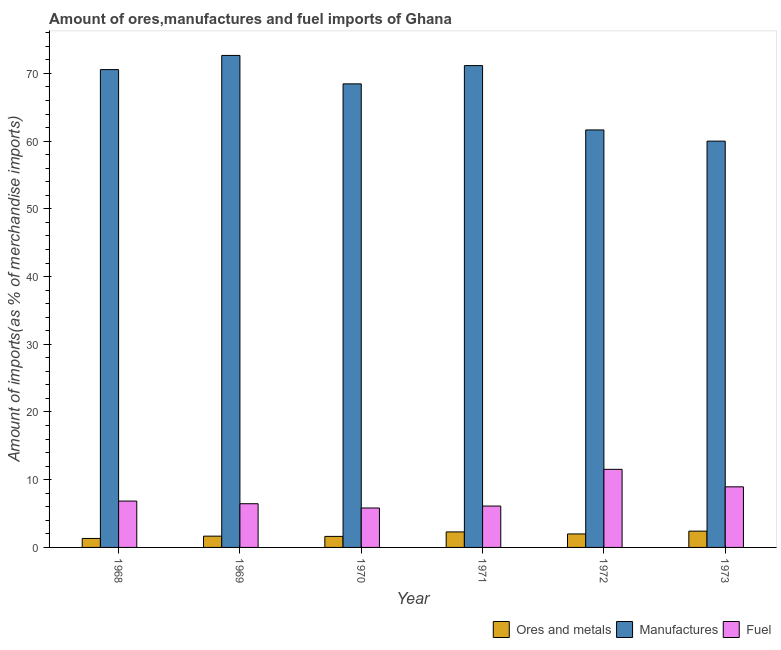How many different coloured bars are there?
Ensure brevity in your answer.  3. Are the number of bars per tick equal to the number of legend labels?
Provide a succinct answer. Yes. Are the number of bars on each tick of the X-axis equal?
Ensure brevity in your answer.  Yes. How many bars are there on the 4th tick from the right?
Provide a short and direct response. 3. What is the label of the 1st group of bars from the left?
Ensure brevity in your answer.  1968. In how many cases, is the number of bars for a given year not equal to the number of legend labels?
Your response must be concise. 0. What is the percentage of fuel imports in 1973?
Your answer should be very brief. 8.95. Across all years, what is the maximum percentage of ores and metals imports?
Give a very brief answer. 2.41. Across all years, what is the minimum percentage of fuel imports?
Give a very brief answer. 5.82. In which year was the percentage of fuel imports maximum?
Give a very brief answer. 1972. What is the total percentage of manufactures imports in the graph?
Offer a terse response. 404.46. What is the difference between the percentage of fuel imports in 1968 and that in 1972?
Keep it short and to the point. -4.69. What is the difference between the percentage of ores and metals imports in 1973 and the percentage of fuel imports in 1970?
Your response must be concise. 0.78. What is the average percentage of manufactures imports per year?
Keep it short and to the point. 67.41. In the year 1971, what is the difference between the percentage of ores and metals imports and percentage of fuel imports?
Your response must be concise. 0. In how many years, is the percentage of fuel imports greater than 68 %?
Keep it short and to the point. 0. What is the ratio of the percentage of fuel imports in 1969 to that in 1973?
Your answer should be compact. 0.72. Is the difference between the percentage of fuel imports in 1969 and 1970 greater than the difference between the percentage of manufactures imports in 1969 and 1970?
Make the answer very short. No. What is the difference between the highest and the second highest percentage of ores and metals imports?
Make the answer very short. 0.11. What is the difference between the highest and the lowest percentage of fuel imports?
Provide a short and direct response. 5.71. In how many years, is the percentage of fuel imports greater than the average percentage of fuel imports taken over all years?
Offer a terse response. 2. Is the sum of the percentage of fuel imports in 1969 and 1972 greater than the maximum percentage of ores and metals imports across all years?
Your answer should be compact. Yes. What does the 3rd bar from the left in 1970 represents?
Give a very brief answer. Fuel. What does the 2nd bar from the right in 1972 represents?
Your answer should be compact. Manufactures. How many bars are there?
Keep it short and to the point. 18. Does the graph contain any zero values?
Your answer should be very brief. No. How many legend labels are there?
Keep it short and to the point. 3. How are the legend labels stacked?
Ensure brevity in your answer.  Horizontal. What is the title of the graph?
Keep it short and to the point. Amount of ores,manufactures and fuel imports of Ghana. What is the label or title of the Y-axis?
Your answer should be compact. Amount of imports(as % of merchandise imports). What is the Amount of imports(as % of merchandise imports) of Ores and metals in 1968?
Offer a terse response. 1.33. What is the Amount of imports(as % of merchandise imports) in Manufactures in 1968?
Keep it short and to the point. 70.56. What is the Amount of imports(as % of merchandise imports) of Fuel in 1968?
Your answer should be very brief. 6.84. What is the Amount of imports(as % of merchandise imports) of Ores and metals in 1969?
Make the answer very short. 1.67. What is the Amount of imports(as % of merchandise imports) of Manufactures in 1969?
Provide a succinct answer. 72.65. What is the Amount of imports(as % of merchandise imports) in Fuel in 1969?
Your response must be concise. 6.45. What is the Amount of imports(as % of merchandise imports) in Ores and metals in 1970?
Provide a short and direct response. 1.63. What is the Amount of imports(as % of merchandise imports) in Manufactures in 1970?
Make the answer very short. 68.45. What is the Amount of imports(as % of merchandise imports) in Fuel in 1970?
Your answer should be very brief. 5.82. What is the Amount of imports(as % of merchandise imports) of Ores and metals in 1971?
Ensure brevity in your answer.  2.29. What is the Amount of imports(as % of merchandise imports) of Manufactures in 1971?
Give a very brief answer. 71.15. What is the Amount of imports(as % of merchandise imports) of Fuel in 1971?
Keep it short and to the point. 6.11. What is the Amount of imports(as % of merchandise imports) of Ores and metals in 1972?
Your answer should be compact. 1.99. What is the Amount of imports(as % of merchandise imports) of Manufactures in 1972?
Your answer should be very brief. 61.65. What is the Amount of imports(as % of merchandise imports) in Fuel in 1972?
Offer a very short reply. 11.53. What is the Amount of imports(as % of merchandise imports) in Ores and metals in 1973?
Ensure brevity in your answer.  2.41. What is the Amount of imports(as % of merchandise imports) of Manufactures in 1973?
Offer a terse response. 60. What is the Amount of imports(as % of merchandise imports) of Fuel in 1973?
Offer a very short reply. 8.95. Across all years, what is the maximum Amount of imports(as % of merchandise imports) in Ores and metals?
Provide a succinct answer. 2.41. Across all years, what is the maximum Amount of imports(as % of merchandise imports) of Manufactures?
Keep it short and to the point. 72.65. Across all years, what is the maximum Amount of imports(as % of merchandise imports) in Fuel?
Your answer should be compact. 11.53. Across all years, what is the minimum Amount of imports(as % of merchandise imports) of Ores and metals?
Give a very brief answer. 1.33. Across all years, what is the minimum Amount of imports(as % of merchandise imports) in Manufactures?
Offer a very short reply. 60. Across all years, what is the minimum Amount of imports(as % of merchandise imports) in Fuel?
Make the answer very short. 5.82. What is the total Amount of imports(as % of merchandise imports) of Ores and metals in the graph?
Your answer should be very brief. 11.31. What is the total Amount of imports(as % of merchandise imports) in Manufactures in the graph?
Make the answer very short. 404.46. What is the total Amount of imports(as % of merchandise imports) in Fuel in the graph?
Provide a short and direct response. 45.71. What is the difference between the Amount of imports(as % of merchandise imports) of Ores and metals in 1968 and that in 1969?
Ensure brevity in your answer.  -0.34. What is the difference between the Amount of imports(as % of merchandise imports) in Manufactures in 1968 and that in 1969?
Give a very brief answer. -2.09. What is the difference between the Amount of imports(as % of merchandise imports) of Fuel in 1968 and that in 1969?
Your answer should be compact. 0.39. What is the difference between the Amount of imports(as % of merchandise imports) in Ores and metals in 1968 and that in 1970?
Make the answer very short. -0.3. What is the difference between the Amount of imports(as % of merchandise imports) of Manufactures in 1968 and that in 1970?
Ensure brevity in your answer.  2.1. What is the difference between the Amount of imports(as % of merchandise imports) of Fuel in 1968 and that in 1970?
Offer a terse response. 1.02. What is the difference between the Amount of imports(as % of merchandise imports) of Ores and metals in 1968 and that in 1971?
Ensure brevity in your answer.  -0.96. What is the difference between the Amount of imports(as % of merchandise imports) in Manufactures in 1968 and that in 1971?
Provide a succinct answer. -0.59. What is the difference between the Amount of imports(as % of merchandise imports) of Fuel in 1968 and that in 1971?
Provide a succinct answer. 0.74. What is the difference between the Amount of imports(as % of merchandise imports) in Ores and metals in 1968 and that in 1972?
Give a very brief answer. -0.67. What is the difference between the Amount of imports(as % of merchandise imports) of Manufactures in 1968 and that in 1972?
Keep it short and to the point. 8.91. What is the difference between the Amount of imports(as % of merchandise imports) in Fuel in 1968 and that in 1972?
Keep it short and to the point. -4.69. What is the difference between the Amount of imports(as % of merchandise imports) of Ores and metals in 1968 and that in 1973?
Keep it short and to the point. -1.08. What is the difference between the Amount of imports(as % of merchandise imports) in Manufactures in 1968 and that in 1973?
Ensure brevity in your answer.  10.56. What is the difference between the Amount of imports(as % of merchandise imports) of Fuel in 1968 and that in 1973?
Your answer should be very brief. -2.1. What is the difference between the Amount of imports(as % of merchandise imports) of Ores and metals in 1969 and that in 1970?
Give a very brief answer. 0.04. What is the difference between the Amount of imports(as % of merchandise imports) in Manufactures in 1969 and that in 1970?
Provide a short and direct response. 4.2. What is the difference between the Amount of imports(as % of merchandise imports) in Fuel in 1969 and that in 1970?
Your answer should be compact. 0.63. What is the difference between the Amount of imports(as % of merchandise imports) of Ores and metals in 1969 and that in 1971?
Your response must be concise. -0.63. What is the difference between the Amount of imports(as % of merchandise imports) of Manufactures in 1969 and that in 1971?
Ensure brevity in your answer.  1.5. What is the difference between the Amount of imports(as % of merchandise imports) in Fuel in 1969 and that in 1971?
Offer a very short reply. 0.34. What is the difference between the Amount of imports(as % of merchandise imports) of Ores and metals in 1969 and that in 1972?
Give a very brief answer. -0.33. What is the difference between the Amount of imports(as % of merchandise imports) in Manufactures in 1969 and that in 1972?
Your answer should be compact. 11. What is the difference between the Amount of imports(as % of merchandise imports) of Fuel in 1969 and that in 1972?
Give a very brief answer. -5.08. What is the difference between the Amount of imports(as % of merchandise imports) in Ores and metals in 1969 and that in 1973?
Your answer should be compact. -0.74. What is the difference between the Amount of imports(as % of merchandise imports) in Manufactures in 1969 and that in 1973?
Your answer should be compact. 12.66. What is the difference between the Amount of imports(as % of merchandise imports) in Fuel in 1969 and that in 1973?
Provide a succinct answer. -2.49. What is the difference between the Amount of imports(as % of merchandise imports) of Ores and metals in 1970 and that in 1971?
Make the answer very short. -0.66. What is the difference between the Amount of imports(as % of merchandise imports) in Manufactures in 1970 and that in 1971?
Keep it short and to the point. -2.7. What is the difference between the Amount of imports(as % of merchandise imports) in Fuel in 1970 and that in 1971?
Keep it short and to the point. -0.29. What is the difference between the Amount of imports(as % of merchandise imports) of Ores and metals in 1970 and that in 1972?
Make the answer very short. -0.36. What is the difference between the Amount of imports(as % of merchandise imports) of Manufactures in 1970 and that in 1972?
Keep it short and to the point. 6.8. What is the difference between the Amount of imports(as % of merchandise imports) in Fuel in 1970 and that in 1972?
Give a very brief answer. -5.71. What is the difference between the Amount of imports(as % of merchandise imports) of Ores and metals in 1970 and that in 1973?
Provide a short and direct response. -0.78. What is the difference between the Amount of imports(as % of merchandise imports) of Manufactures in 1970 and that in 1973?
Your answer should be very brief. 8.46. What is the difference between the Amount of imports(as % of merchandise imports) of Fuel in 1970 and that in 1973?
Offer a very short reply. -3.12. What is the difference between the Amount of imports(as % of merchandise imports) of Ores and metals in 1971 and that in 1972?
Your answer should be compact. 0.3. What is the difference between the Amount of imports(as % of merchandise imports) of Manufactures in 1971 and that in 1972?
Offer a very short reply. 9.5. What is the difference between the Amount of imports(as % of merchandise imports) in Fuel in 1971 and that in 1972?
Make the answer very short. -5.42. What is the difference between the Amount of imports(as % of merchandise imports) in Ores and metals in 1971 and that in 1973?
Make the answer very short. -0.11. What is the difference between the Amount of imports(as % of merchandise imports) of Manufactures in 1971 and that in 1973?
Your response must be concise. 11.16. What is the difference between the Amount of imports(as % of merchandise imports) of Fuel in 1971 and that in 1973?
Your answer should be very brief. -2.84. What is the difference between the Amount of imports(as % of merchandise imports) of Ores and metals in 1972 and that in 1973?
Offer a very short reply. -0.41. What is the difference between the Amount of imports(as % of merchandise imports) of Manufactures in 1972 and that in 1973?
Offer a very short reply. 1.65. What is the difference between the Amount of imports(as % of merchandise imports) in Fuel in 1972 and that in 1973?
Keep it short and to the point. 2.58. What is the difference between the Amount of imports(as % of merchandise imports) of Ores and metals in 1968 and the Amount of imports(as % of merchandise imports) of Manufactures in 1969?
Make the answer very short. -71.33. What is the difference between the Amount of imports(as % of merchandise imports) in Ores and metals in 1968 and the Amount of imports(as % of merchandise imports) in Fuel in 1969?
Keep it short and to the point. -5.13. What is the difference between the Amount of imports(as % of merchandise imports) of Manufactures in 1968 and the Amount of imports(as % of merchandise imports) of Fuel in 1969?
Provide a short and direct response. 64.1. What is the difference between the Amount of imports(as % of merchandise imports) of Ores and metals in 1968 and the Amount of imports(as % of merchandise imports) of Manufactures in 1970?
Give a very brief answer. -67.13. What is the difference between the Amount of imports(as % of merchandise imports) in Ores and metals in 1968 and the Amount of imports(as % of merchandise imports) in Fuel in 1970?
Make the answer very short. -4.5. What is the difference between the Amount of imports(as % of merchandise imports) of Manufactures in 1968 and the Amount of imports(as % of merchandise imports) of Fuel in 1970?
Offer a very short reply. 64.73. What is the difference between the Amount of imports(as % of merchandise imports) of Ores and metals in 1968 and the Amount of imports(as % of merchandise imports) of Manufactures in 1971?
Offer a terse response. -69.82. What is the difference between the Amount of imports(as % of merchandise imports) of Ores and metals in 1968 and the Amount of imports(as % of merchandise imports) of Fuel in 1971?
Provide a succinct answer. -4.78. What is the difference between the Amount of imports(as % of merchandise imports) in Manufactures in 1968 and the Amount of imports(as % of merchandise imports) in Fuel in 1971?
Give a very brief answer. 64.45. What is the difference between the Amount of imports(as % of merchandise imports) of Ores and metals in 1968 and the Amount of imports(as % of merchandise imports) of Manufactures in 1972?
Your answer should be very brief. -60.32. What is the difference between the Amount of imports(as % of merchandise imports) in Ores and metals in 1968 and the Amount of imports(as % of merchandise imports) in Fuel in 1972?
Provide a short and direct response. -10.21. What is the difference between the Amount of imports(as % of merchandise imports) in Manufactures in 1968 and the Amount of imports(as % of merchandise imports) in Fuel in 1972?
Offer a very short reply. 59.03. What is the difference between the Amount of imports(as % of merchandise imports) of Ores and metals in 1968 and the Amount of imports(as % of merchandise imports) of Manufactures in 1973?
Ensure brevity in your answer.  -58.67. What is the difference between the Amount of imports(as % of merchandise imports) of Ores and metals in 1968 and the Amount of imports(as % of merchandise imports) of Fuel in 1973?
Offer a terse response. -7.62. What is the difference between the Amount of imports(as % of merchandise imports) in Manufactures in 1968 and the Amount of imports(as % of merchandise imports) in Fuel in 1973?
Make the answer very short. 61.61. What is the difference between the Amount of imports(as % of merchandise imports) in Ores and metals in 1969 and the Amount of imports(as % of merchandise imports) in Manufactures in 1970?
Give a very brief answer. -66.79. What is the difference between the Amount of imports(as % of merchandise imports) in Ores and metals in 1969 and the Amount of imports(as % of merchandise imports) in Fuel in 1970?
Your response must be concise. -4.16. What is the difference between the Amount of imports(as % of merchandise imports) of Manufactures in 1969 and the Amount of imports(as % of merchandise imports) of Fuel in 1970?
Your answer should be very brief. 66.83. What is the difference between the Amount of imports(as % of merchandise imports) of Ores and metals in 1969 and the Amount of imports(as % of merchandise imports) of Manufactures in 1971?
Give a very brief answer. -69.48. What is the difference between the Amount of imports(as % of merchandise imports) in Ores and metals in 1969 and the Amount of imports(as % of merchandise imports) in Fuel in 1971?
Provide a succinct answer. -4.44. What is the difference between the Amount of imports(as % of merchandise imports) of Manufactures in 1969 and the Amount of imports(as % of merchandise imports) of Fuel in 1971?
Offer a very short reply. 66.54. What is the difference between the Amount of imports(as % of merchandise imports) of Ores and metals in 1969 and the Amount of imports(as % of merchandise imports) of Manufactures in 1972?
Provide a succinct answer. -59.98. What is the difference between the Amount of imports(as % of merchandise imports) in Ores and metals in 1969 and the Amount of imports(as % of merchandise imports) in Fuel in 1972?
Offer a terse response. -9.87. What is the difference between the Amount of imports(as % of merchandise imports) of Manufactures in 1969 and the Amount of imports(as % of merchandise imports) of Fuel in 1972?
Your response must be concise. 61.12. What is the difference between the Amount of imports(as % of merchandise imports) of Ores and metals in 1969 and the Amount of imports(as % of merchandise imports) of Manufactures in 1973?
Offer a very short reply. -58.33. What is the difference between the Amount of imports(as % of merchandise imports) of Ores and metals in 1969 and the Amount of imports(as % of merchandise imports) of Fuel in 1973?
Ensure brevity in your answer.  -7.28. What is the difference between the Amount of imports(as % of merchandise imports) in Manufactures in 1969 and the Amount of imports(as % of merchandise imports) in Fuel in 1973?
Your response must be concise. 63.7. What is the difference between the Amount of imports(as % of merchandise imports) in Ores and metals in 1970 and the Amount of imports(as % of merchandise imports) in Manufactures in 1971?
Offer a very short reply. -69.52. What is the difference between the Amount of imports(as % of merchandise imports) in Ores and metals in 1970 and the Amount of imports(as % of merchandise imports) in Fuel in 1971?
Offer a terse response. -4.48. What is the difference between the Amount of imports(as % of merchandise imports) in Manufactures in 1970 and the Amount of imports(as % of merchandise imports) in Fuel in 1971?
Keep it short and to the point. 62.34. What is the difference between the Amount of imports(as % of merchandise imports) in Ores and metals in 1970 and the Amount of imports(as % of merchandise imports) in Manufactures in 1972?
Offer a very short reply. -60.02. What is the difference between the Amount of imports(as % of merchandise imports) in Ores and metals in 1970 and the Amount of imports(as % of merchandise imports) in Fuel in 1972?
Your answer should be compact. -9.9. What is the difference between the Amount of imports(as % of merchandise imports) in Manufactures in 1970 and the Amount of imports(as % of merchandise imports) in Fuel in 1972?
Offer a terse response. 56.92. What is the difference between the Amount of imports(as % of merchandise imports) of Ores and metals in 1970 and the Amount of imports(as % of merchandise imports) of Manufactures in 1973?
Your answer should be very brief. -58.37. What is the difference between the Amount of imports(as % of merchandise imports) of Ores and metals in 1970 and the Amount of imports(as % of merchandise imports) of Fuel in 1973?
Offer a terse response. -7.32. What is the difference between the Amount of imports(as % of merchandise imports) of Manufactures in 1970 and the Amount of imports(as % of merchandise imports) of Fuel in 1973?
Your response must be concise. 59.51. What is the difference between the Amount of imports(as % of merchandise imports) of Ores and metals in 1971 and the Amount of imports(as % of merchandise imports) of Manufactures in 1972?
Your answer should be very brief. -59.36. What is the difference between the Amount of imports(as % of merchandise imports) of Ores and metals in 1971 and the Amount of imports(as % of merchandise imports) of Fuel in 1972?
Ensure brevity in your answer.  -9.24. What is the difference between the Amount of imports(as % of merchandise imports) of Manufactures in 1971 and the Amount of imports(as % of merchandise imports) of Fuel in 1972?
Offer a terse response. 59.62. What is the difference between the Amount of imports(as % of merchandise imports) of Ores and metals in 1971 and the Amount of imports(as % of merchandise imports) of Manufactures in 1973?
Your answer should be very brief. -57.7. What is the difference between the Amount of imports(as % of merchandise imports) of Ores and metals in 1971 and the Amount of imports(as % of merchandise imports) of Fuel in 1973?
Give a very brief answer. -6.66. What is the difference between the Amount of imports(as % of merchandise imports) in Manufactures in 1971 and the Amount of imports(as % of merchandise imports) in Fuel in 1973?
Provide a succinct answer. 62.2. What is the difference between the Amount of imports(as % of merchandise imports) of Ores and metals in 1972 and the Amount of imports(as % of merchandise imports) of Manufactures in 1973?
Provide a short and direct response. -58. What is the difference between the Amount of imports(as % of merchandise imports) in Ores and metals in 1972 and the Amount of imports(as % of merchandise imports) in Fuel in 1973?
Your response must be concise. -6.96. What is the difference between the Amount of imports(as % of merchandise imports) of Manufactures in 1972 and the Amount of imports(as % of merchandise imports) of Fuel in 1973?
Offer a terse response. 52.7. What is the average Amount of imports(as % of merchandise imports) of Ores and metals per year?
Offer a terse response. 1.88. What is the average Amount of imports(as % of merchandise imports) of Manufactures per year?
Make the answer very short. 67.41. What is the average Amount of imports(as % of merchandise imports) of Fuel per year?
Your answer should be compact. 7.62. In the year 1968, what is the difference between the Amount of imports(as % of merchandise imports) in Ores and metals and Amount of imports(as % of merchandise imports) in Manufactures?
Provide a succinct answer. -69.23. In the year 1968, what is the difference between the Amount of imports(as % of merchandise imports) of Ores and metals and Amount of imports(as % of merchandise imports) of Fuel?
Your answer should be very brief. -5.52. In the year 1968, what is the difference between the Amount of imports(as % of merchandise imports) of Manufactures and Amount of imports(as % of merchandise imports) of Fuel?
Give a very brief answer. 63.71. In the year 1969, what is the difference between the Amount of imports(as % of merchandise imports) in Ores and metals and Amount of imports(as % of merchandise imports) in Manufactures?
Offer a terse response. -70.99. In the year 1969, what is the difference between the Amount of imports(as % of merchandise imports) in Ores and metals and Amount of imports(as % of merchandise imports) in Fuel?
Your answer should be compact. -4.79. In the year 1969, what is the difference between the Amount of imports(as % of merchandise imports) in Manufactures and Amount of imports(as % of merchandise imports) in Fuel?
Ensure brevity in your answer.  66.2. In the year 1970, what is the difference between the Amount of imports(as % of merchandise imports) of Ores and metals and Amount of imports(as % of merchandise imports) of Manufactures?
Your answer should be compact. -66.82. In the year 1970, what is the difference between the Amount of imports(as % of merchandise imports) in Ores and metals and Amount of imports(as % of merchandise imports) in Fuel?
Your response must be concise. -4.19. In the year 1970, what is the difference between the Amount of imports(as % of merchandise imports) in Manufactures and Amount of imports(as % of merchandise imports) in Fuel?
Your answer should be very brief. 62.63. In the year 1971, what is the difference between the Amount of imports(as % of merchandise imports) of Ores and metals and Amount of imports(as % of merchandise imports) of Manufactures?
Provide a short and direct response. -68.86. In the year 1971, what is the difference between the Amount of imports(as % of merchandise imports) in Ores and metals and Amount of imports(as % of merchandise imports) in Fuel?
Give a very brief answer. -3.82. In the year 1971, what is the difference between the Amount of imports(as % of merchandise imports) in Manufactures and Amount of imports(as % of merchandise imports) in Fuel?
Keep it short and to the point. 65.04. In the year 1972, what is the difference between the Amount of imports(as % of merchandise imports) in Ores and metals and Amount of imports(as % of merchandise imports) in Manufactures?
Make the answer very short. -59.66. In the year 1972, what is the difference between the Amount of imports(as % of merchandise imports) of Ores and metals and Amount of imports(as % of merchandise imports) of Fuel?
Give a very brief answer. -9.54. In the year 1972, what is the difference between the Amount of imports(as % of merchandise imports) in Manufactures and Amount of imports(as % of merchandise imports) in Fuel?
Your answer should be very brief. 50.12. In the year 1973, what is the difference between the Amount of imports(as % of merchandise imports) of Ores and metals and Amount of imports(as % of merchandise imports) of Manufactures?
Provide a succinct answer. -57.59. In the year 1973, what is the difference between the Amount of imports(as % of merchandise imports) in Ores and metals and Amount of imports(as % of merchandise imports) in Fuel?
Give a very brief answer. -6.54. In the year 1973, what is the difference between the Amount of imports(as % of merchandise imports) of Manufactures and Amount of imports(as % of merchandise imports) of Fuel?
Make the answer very short. 51.05. What is the ratio of the Amount of imports(as % of merchandise imports) of Ores and metals in 1968 to that in 1969?
Provide a succinct answer. 0.8. What is the ratio of the Amount of imports(as % of merchandise imports) in Manufactures in 1968 to that in 1969?
Ensure brevity in your answer.  0.97. What is the ratio of the Amount of imports(as % of merchandise imports) of Fuel in 1968 to that in 1969?
Your response must be concise. 1.06. What is the ratio of the Amount of imports(as % of merchandise imports) of Ores and metals in 1968 to that in 1970?
Give a very brief answer. 0.81. What is the ratio of the Amount of imports(as % of merchandise imports) of Manufactures in 1968 to that in 1970?
Give a very brief answer. 1.03. What is the ratio of the Amount of imports(as % of merchandise imports) in Fuel in 1968 to that in 1970?
Provide a short and direct response. 1.18. What is the ratio of the Amount of imports(as % of merchandise imports) in Ores and metals in 1968 to that in 1971?
Give a very brief answer. 0.58. What is the ratio of the Amount of imports(as % of merchandise imports) of Fuel in 1968 to that in 1971?
Keep it short and to the point. 1.12. What is the ratio of the Amount of imports(as % of merchandise imports) of Ores and metals in 1968 to that in 1972?
Offer a terse response. 0.67. What is the ratio of the Amount of imports(as % of merchandise imports) of Manufactures in 1968 to that in 1972?
Provide a succinct answer. 1.14. What is the ratio of the Amount of imports(as % of merchandise imports) in Fuel in 1968 to that in 1972?
Make the answer very short. 0.59. What is the ratio of the Amount of imports(as % of merchandise imports) of Ores and metals in 1968 to that in 1973?
Offer a very short reply. 0.55. What is the ratio of the Amount of imports(as % of merchandise imports) of Manufactures in 1968 to that in 1973?
Offer a terse response. 1.18. What is the ratio of the Amount of imports(as % of merchandise imports) of Fuel in 1968 to that in 1973?
Offer a terse response. 0.77. What is the ratio of the Amount of imports(as % of merchandise imports) in Ores and metals in 1969 to that in 1970?
Offer a terse response. 1.02. What is the ratio of the Amount of imports(as % of merchandise imports) in Manufactures in 1969 to that in 1970?
Give a very brief answer. 1.06. What is the ratio of the Amount of imports(as % of merchandise imports) in Fuel in 1969 to that in 1970?
Your answer should be compact. 1.11. What is the ratio of the Amount of imports(as % of merchandise imports) in Ores and metals in 1969 to that in 1971?
Provide a short and direct response. 0.73. What is the ratio of the Amount of imports(as % of merchandise imports) of Manufactures in 1969 to that in 1971?
Make the answer very short. 1.02. What is the ratio of the Amount of imports(as % of merchandise imports) in Fuel in 1969 to that in 1971?
Give a very brief answer. 1.06. What is the ratio of the Amount of imports(as % of merchandise imports) of Ores and metals in 1969 to that in 1972?
Keep it short and to the point. 0.84. What is the ratio of the Amount of imports(as % of merchandise imports) in Manufactures in 1969 to that in 1972?
Your response must be concise. 1.18. What is the ratio of the Amount of imports(as % of merchandise imports) of Fuel in 1969 to that in 1972?
Make the answer very short. 0.56. What is the ratio of the Amount of imports(as % of merchandise imports) of Ores and metals in 1969 to that in 1973?
Provide a short and direct response. 0.69. What is the ratio of the Amount of imports(as % of merchandise imports) in Manufactures in 1969 to that in 1973?
Make the answer very short. 1.21. What is the ratio of the Amount of imports(as % of merchandise imports) of Fuel in 1969 to that in 1973?
Your response must be concise. 0.72. What is the ratio of the Amount of imports(as % of merchandise imports) in Ores and metals in 1970 to that in 1971?
Ensure brevity in your answer.  0.71. What is the ratio of the Amount of imports(as % of merchandise imports) of Manufactures in 1970 to that in 1971?
Give a very brief answer. 0.96. What is the ratio of the Amount of imports(as % of merchandise imports) in Fuel in 1970 to that in 1971?
Offer a terse response. 0.95. What is the ratio of the Amount of imports(as % of merchandise imports) in Ores and metals in 1970 to that in 1972?
Offer a very short reply. 0.82. What is the ratio of the Amount of imports(as % of merchandise imports) of Manufactures in 1970 to that in 1972?
Your answer should be very brief. 1.11. What is the ratio of the Amount of imports(as % of merchandise imports) of Fuel in 1970 to that in 1972?
Provide a short and direct response. 0.51. What is the ratio of the Amount of imports(as % of merchandise imports) in Ores and metals in 1970 to that in 1973?
Your response must be concise. 0.68. What is the ratio of the Amount of imports(as % of merchandise imports) of Manufactures in 1970 to that in 1973?
Provide a short and direct response. 1.14. What is the ratio of the Amount of imports(as % of merchandise imports) of Fuel in 1970 to that in 1973?
Your answer should be very brief. 0.65. What is the ratio of the Amount of imports(as % of merchandise imports) in Ores and metals in 1971 to that in 1972?
Make the answer very short. 1.15. What is the ratio of the Amount of imports(as % of merchandise imports) in Manufactures in 1971 to that in 1972?
Provide a short and direct response. 1.15. What is the ratio of the Amount of imports(as % of merchandise imports) of Fuel in 1971 to that in 1972?
Ensure brevity in your answer.  0.53. What is the ratio of the Amount of imports(as % of merchandise imports) of Ores and metals in 1971 to that in 1973?
Offer a terse response. 0.95. What is the ratio of the Amount of imports(as % of merchandise imports) in Manufactures in 1971 to that in 1973?
Offer a terse response. 1.19. What is the ratio of the Amount of imports(as % of merchandise imports) of Fuel in 1971 to that in 1973?
Provide a succinct answer. 0.68. What is the ratio of the Amount of imports(as % of merchandise imports) in Ores and metals in 1972 to that in 1973?
Provide a succinct answer. 0.83. What is the ratio of the Amount of imports(as % of merchandise imports) in Manufactures in 1972 to that in 1973?
Offer a terse response. 1.03. What is the ratio of the Amount of imports(as % of merchandise imports) of Fuel in 1972 to that in 1973?
Keep it short and to the point. 1.29. What is the difference between the highest and the second highest Amount of imports(as % of merchandise imports) of Ores and metals?
Your response must be concise. 0.11. What is the difference between the highest and the second highest Amount of imports(as % of merchandise imports) in Manufactures?
Provide a short and direct response. 1.5. What is the difference between the highest and the second highest Amount of imports(as % of merchandise imports) of Fuel?
Ensure brevity in your answer.  2.58. What is the difference between the highest and the lowest Amount of imports(as % of merchandise imports) of Ores and metals?
Give a very brief answer. 1.08. What is the difference between the highest and the lowest Amount of imports(as % of merchandise imports) in Manufactures?
Provide a short and direct response. 12.66. What is the difference between the highest and the lowest Amount of imports(as % of merchandise imports) of Fuel?
Offer a very short reply. 5.71. 